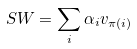Convert formula to latex. <formula><loc_0><loc_0><loc_500><loc_500>S W = \sum _ { i } \alpha _ { i } v _ { \pi ( i ) }</formula> 